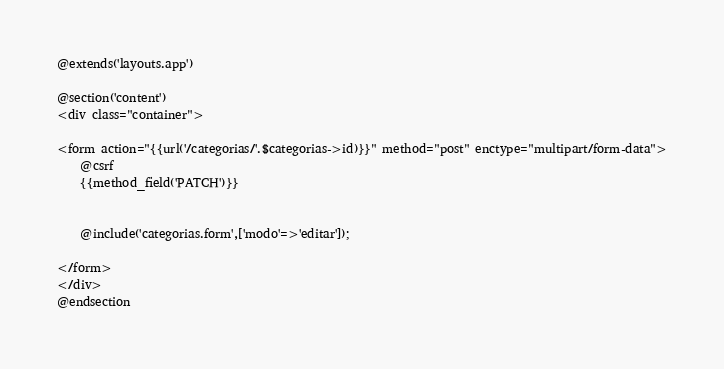<code> <loc_0><loc_0><loc_500><loc_500><_PHP_>@extends('layouts.app')

@section('content')
<div class="container">

<form action="{{url('/categorias/'.$categorias->id)}}" method="post" enctype="multipart/form-data">
    @csrf 
    {{method_field('PATCH')}}

    
    @include('categorias.form',['modo'=>'editar']); 
    
</form>
</div>
@endsection</code> 